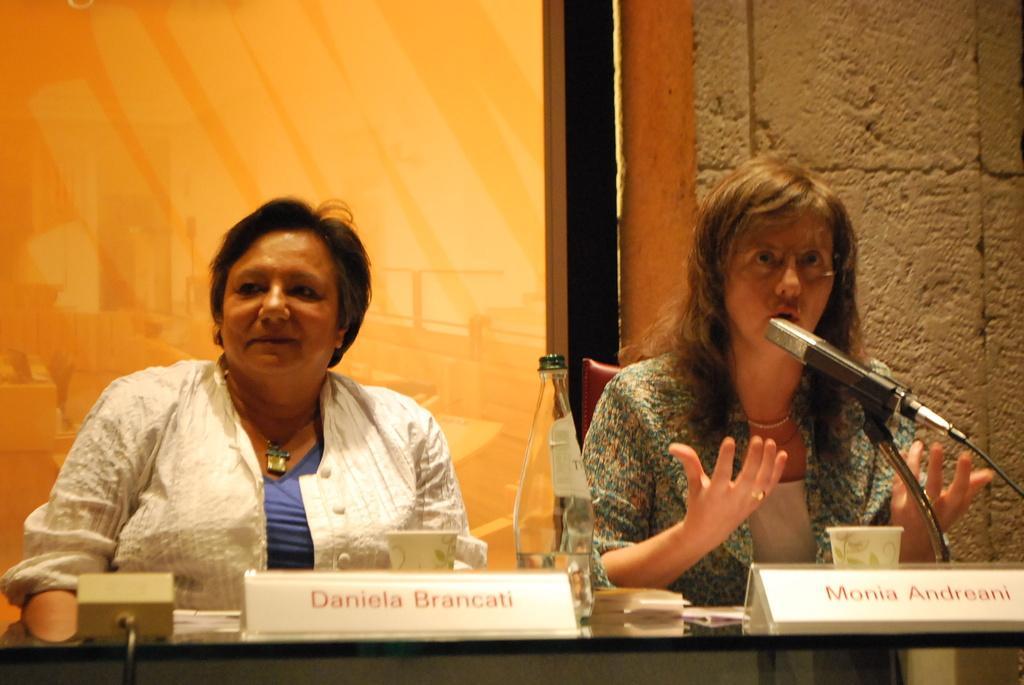Please provide a concise description of this image. At the bottom of the image there is a table with name boards, bottle, cup and few other items. Behind the table at the left side there is a lady with white jacket is sitting. And at the right side of the image there is a lady sitting in front of the mic and she is talking. Behind them at the right side there is a wall. And at the left side there is a glass door. 